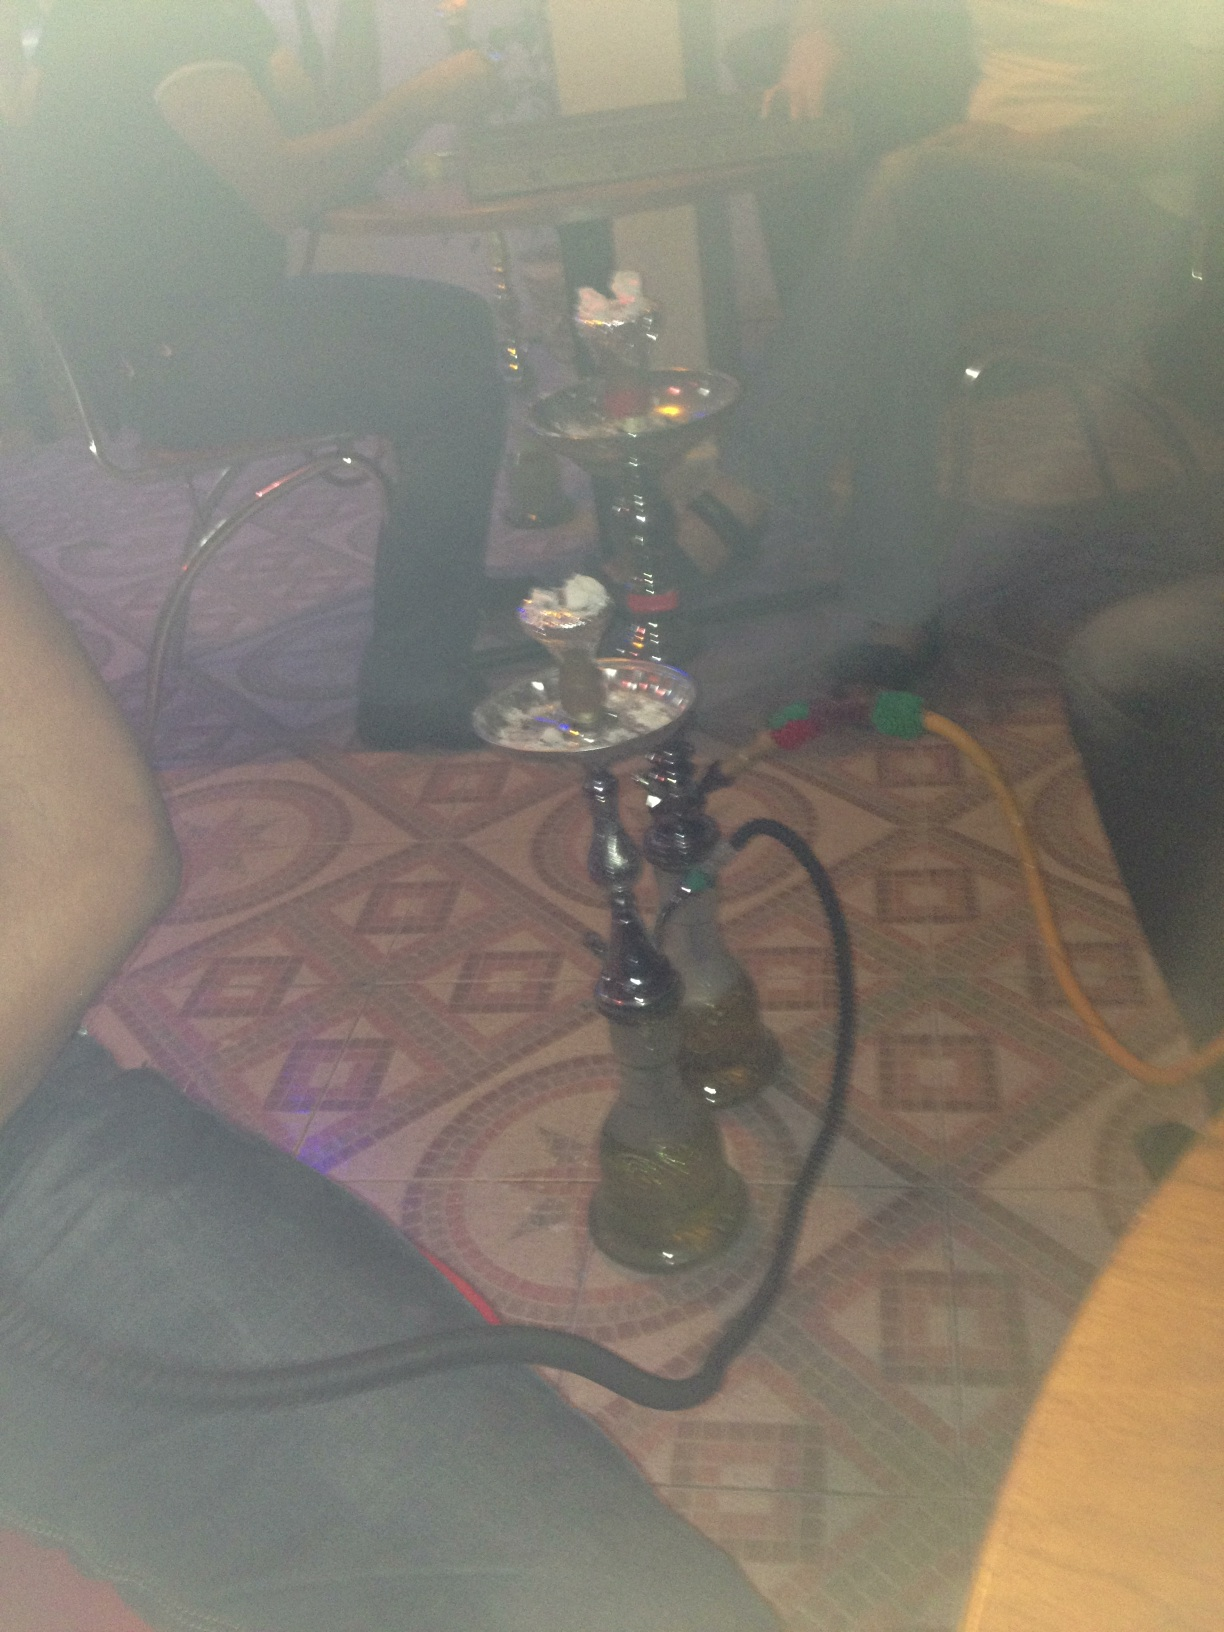What are the potential health impacts of using a hookah? The use of hookah for smoking tobacco poses several health risks, including exposure to harmful chemicals such as carbon monoxide, carcinogens, and heavy metals that result from burning charcoal and tobacco. Prolonged or frequent use can lead to respiratory issues, heart disease, and other health problems. Additionally, sharing mouthpieces without proper sanitation practices increases the risk of transmitting communicable diseases. 